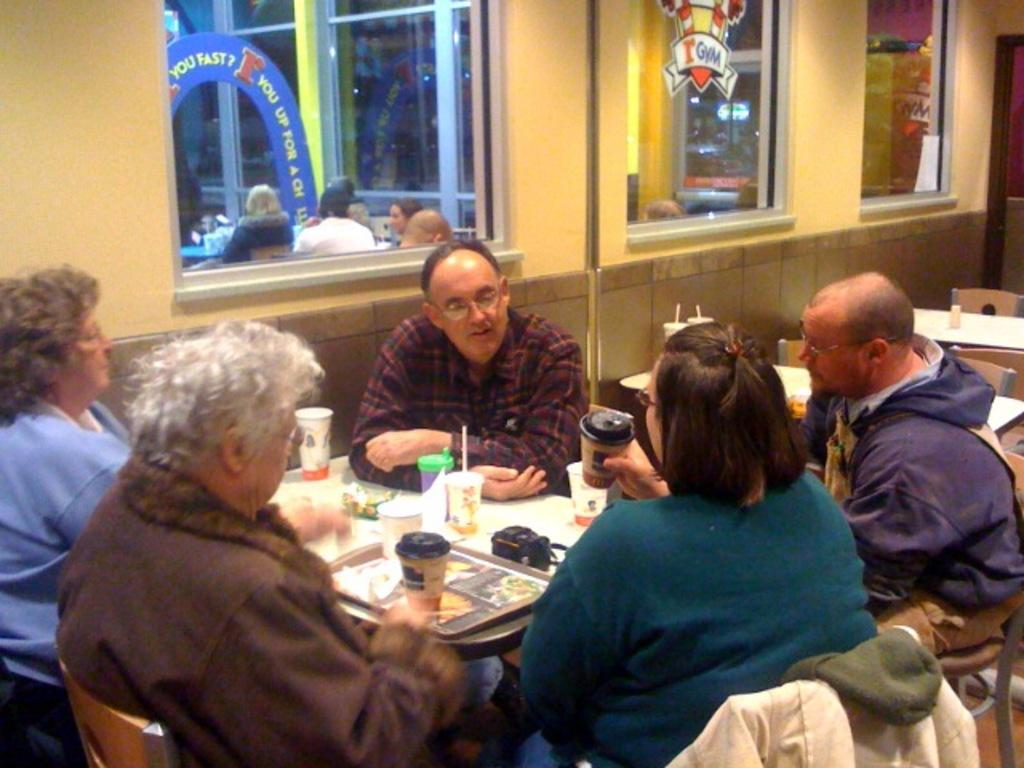What color is the wall that is visible in the image? There is a yellow color wall in the image. What can be seen on the wall in the image? There is a window visible on the wall in the image. What are the people in the image doing? There are people sitting on chairs in the image. What furniture is present in the image? There is a table in the image. What items are on the table in the image? There are plates, glasses, and food items on the table. What type of produce is being harvested in the image? There is no produce or harvesting activity present in the image. What verse is being recited by the people in the image? There is no verse or recitation activity present in the image. 